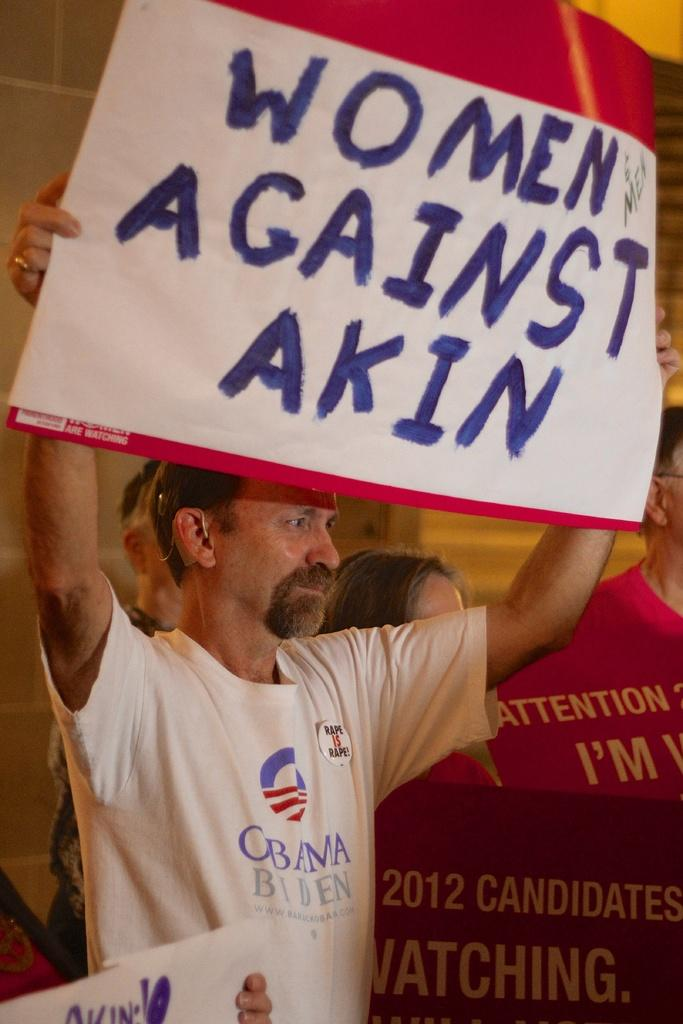Provide a one-sentence caption for the provided image. A man holding up a sign for Women against Akin wearing an Obama Biden shirt. 